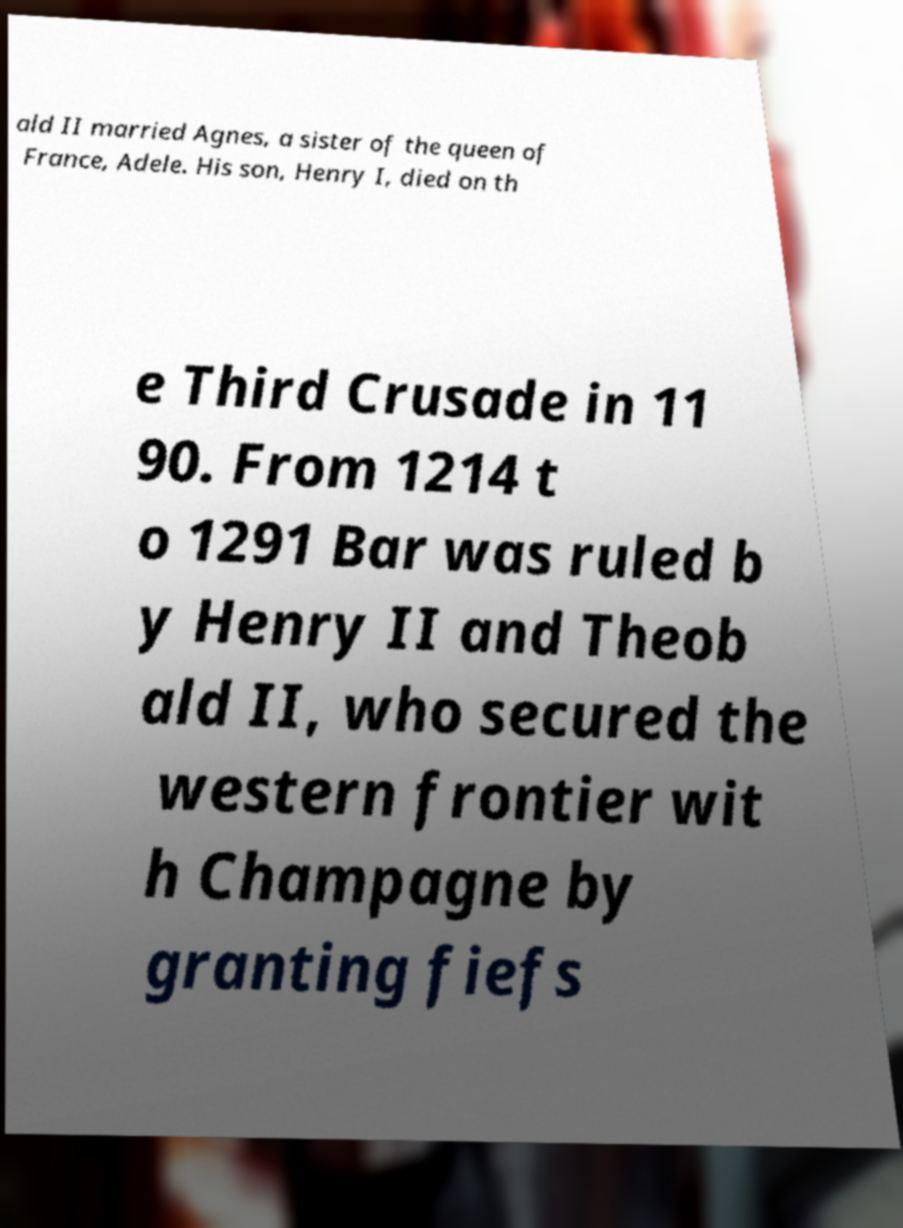Can you accurately transcribe the text from the provided image for me? ald II married Agnes, a sister of the queen of France, Adele. His son, Henry I, died on th e Third Crusade in 11 90. From 1214 t o 1291 Bar was ruled b y Henry II and Theob ald II, who secured the western frontier wit h Champagne by granting fiefs 